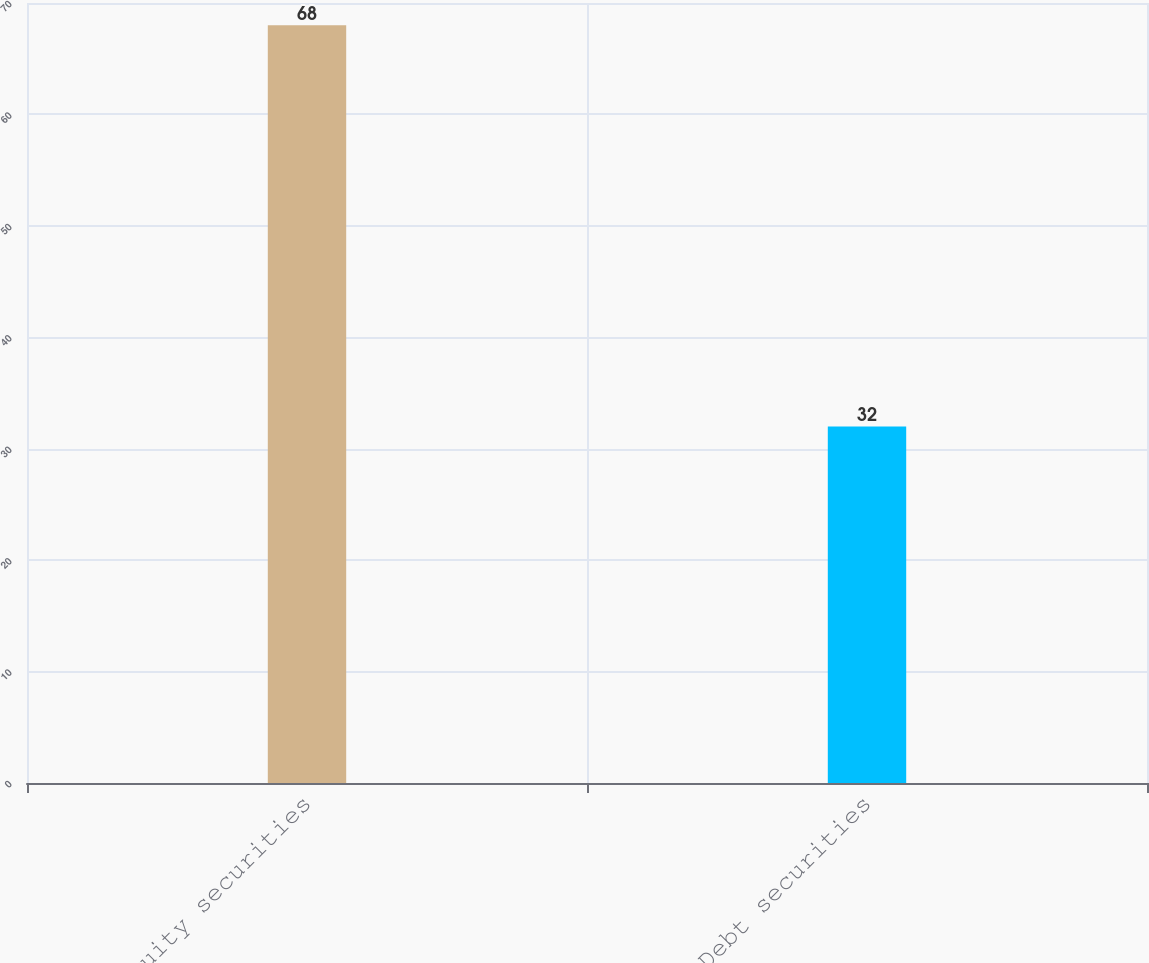Convert chart. <chart><loc_0><loc_0><loc_500><loc_500><bar_chart><fcel>Equity securities<fcel>Debt securities<nl><fcel>68<fcel>32<nl></chart> 